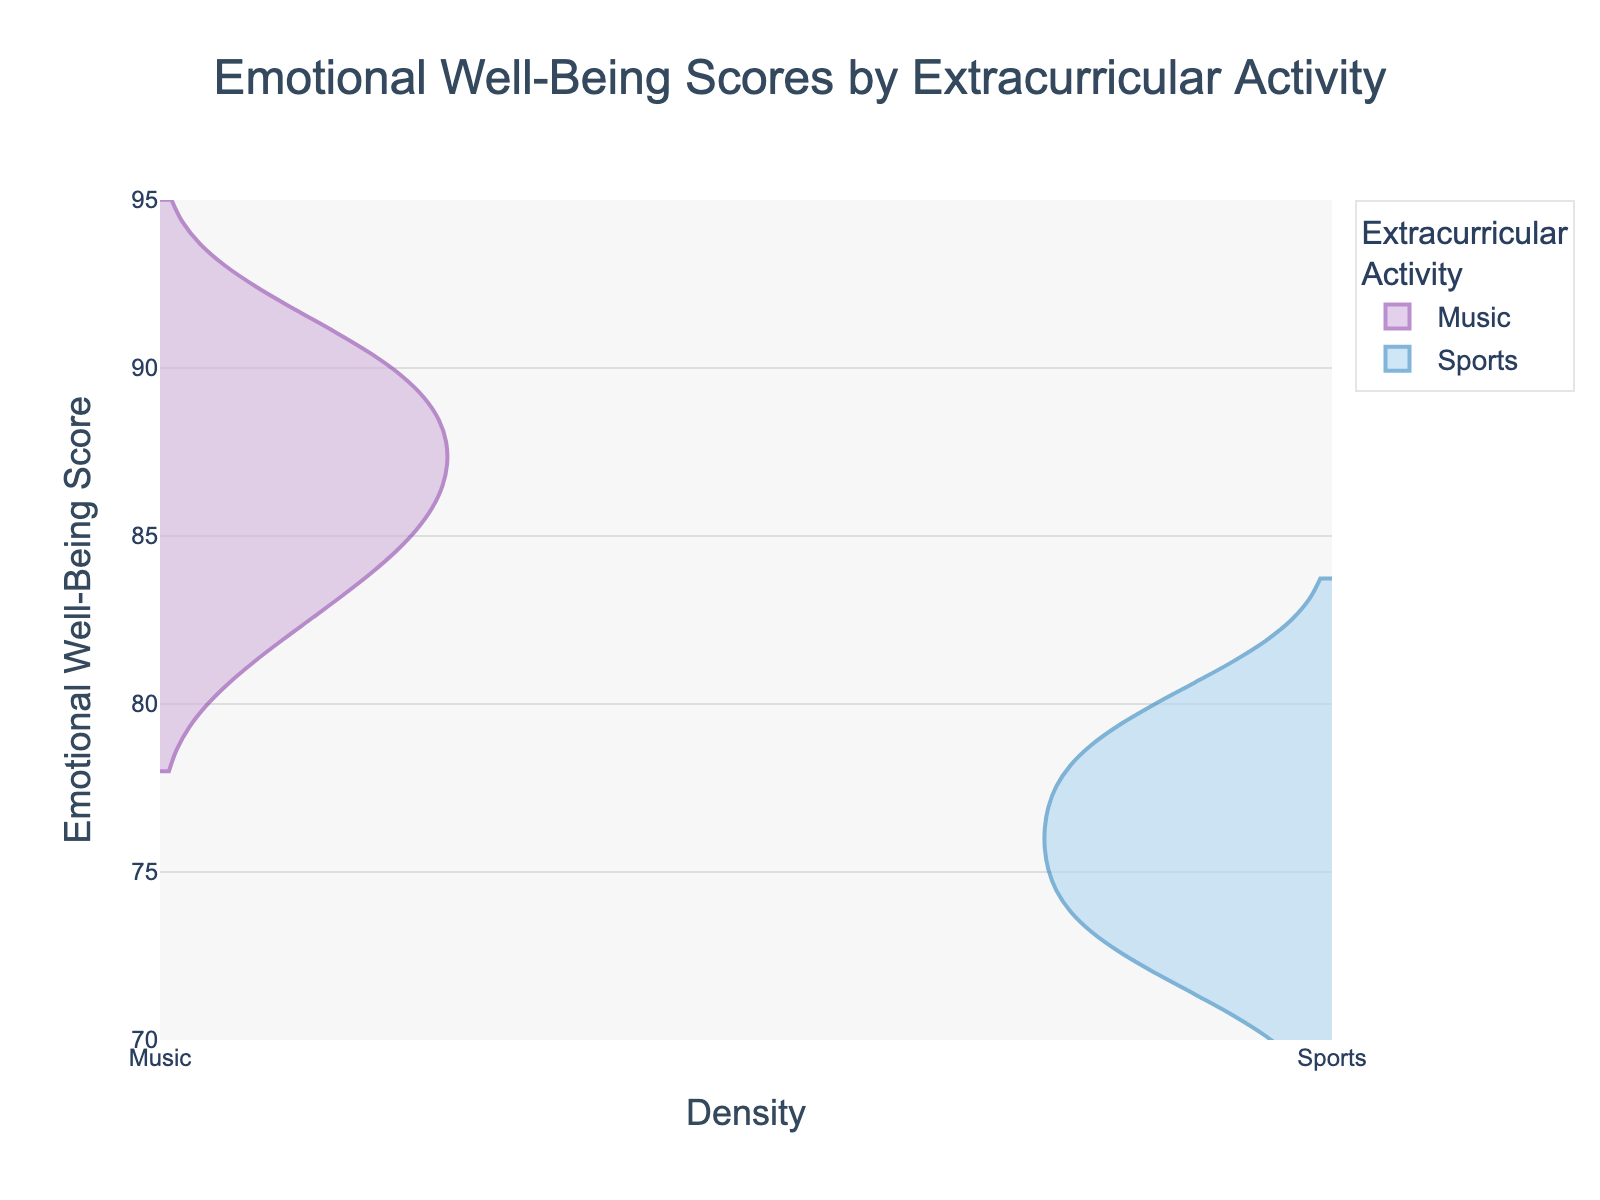What are the two types of extracurricular activities shown in the plot? The plot displays density plots for two groups of extracurricular activities. Each group is represented by a different color. From the legend, the two activities are Music and Sports.
Answer: Music and Sports What is the highest Emotional Well-Being Score for students in Music? To determine the highest score for Music students, locate the peak point of the density plot section labeled 'Music'. This can be observed by looking at the y-axis range the plot covers for Music. The highest point is around 91.
Answer: 91 Which group shows a higher peak in their Emotional Well-Being Scores? By comparing the peaks of the two density plots, it is evident which group has the higher Emotional Well-Being peak score. Music peaks higher than Sports.
Answer: Music What is the range of Emotional Well-Being Scores for students in Sports? The range can be identified by observing the spread of the density plot for Sports on the y-axis. The plot for Sports spans scores from about 72 to about 80.
Answer: 72 to 80 Are there more students in Music or Sports based on the density plot width? The width of the density plot reflects the number of students in each group, as wider plots typically indicate more data points. The plot for Music appears wider than the plot for Sports.
Answer: Music What's the approximate difference between the highest Emotional Well-Being Score of students in Music and those in Sports? First, find the highest scores from both groups: Music (91) and Sports (80). The difference is calculated by subtracting 80 from 91.
Answer: 11 How does the overall Emotional Well-Being of students in Music compare to those in Sports? Generally examine the spread and peaks of both density plots. Music displays higher Emotional Well-Being scores consistently compared to Sports, as indicated by the higher range and peaks.
Answer: Music is higher What can you infer about the Emotional Well-Being Scores of students involved in Music compared to those in Sports? By analyzing both plots, we see that the scores for Music are generally higher and less spread out than for Sports. This can suggest more consistent and higher levels of emotional well-being among students involved in Music.
Answer: Music has higher and more consistent scores 